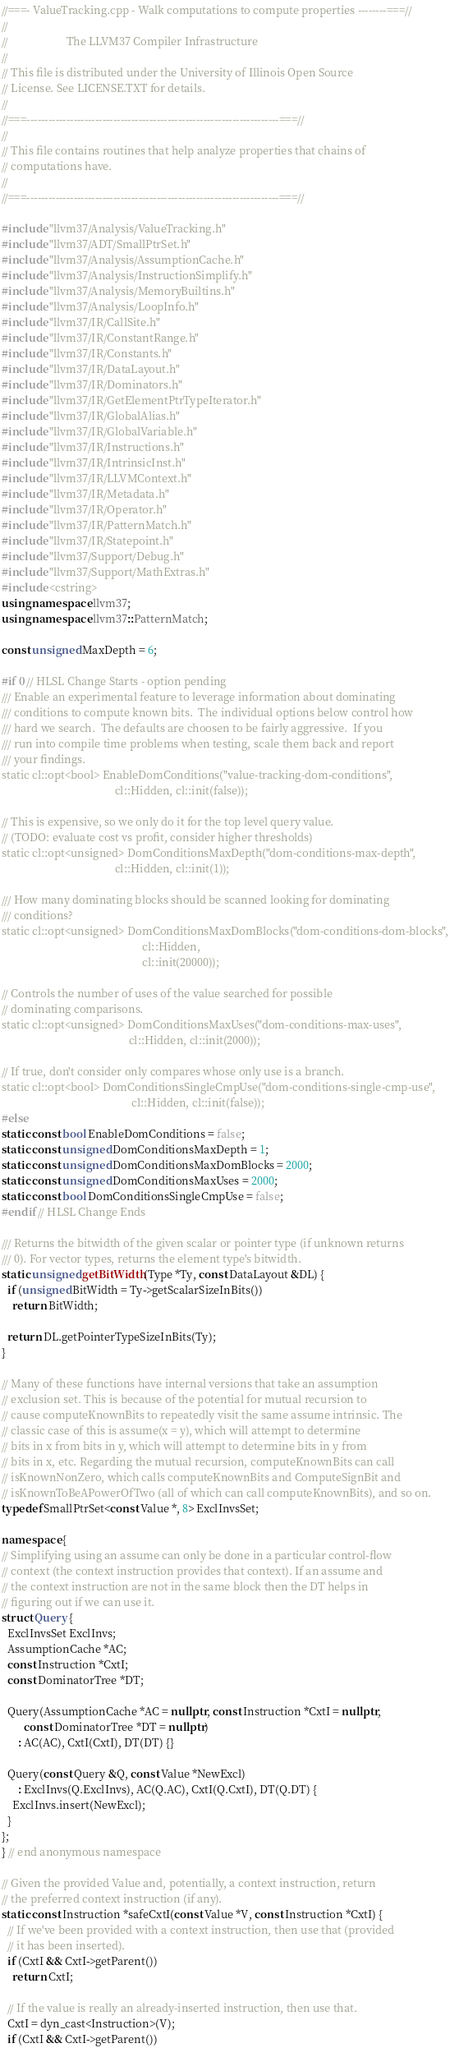Convert code to text. <code><loc_0><loc_0><loc_500><loc_500><_C++_>//===- ValueTracking.cpp - Walk computations to compute properties --------===//
//
//                     The LLVM37 Compiler Infrastructure
//
// This file is distributed under the University of Illinois Open Source
// License. See LICENSE.TXT for details.
//
//===----------------------------------------------------------------------===//
//
// This file contains routines that help analyze properties that chains of
// computations have.
//
//===----------------------------------------------------------------------===//

#include "llvm37/Analysis/ValueTracking.h"
#include "llvm37/ADT/SmallPtrSet.h"
#include "llvm37/Analysis/AssumptionCache.h"
#include "llvm37/Analysis/InstructionSimplify.h"
#include "llvm37/Analysis/MemoryBuiltins.h"
#include "llvm37/Analysis/LoopInfo.h"
#include "llvm37/IR/CallSite.h"
#include "llvm37/IR/ConstantRange.h"
#include "llvm37/IR/Constants.h"
#include "llvm37/IR/DataLayout.h"
#include "llvm37/IR/Dominators.h"
#include "llvm37/IR/GetElementPtrTypeIterator.h"
#include "llvm37/IR/GlobalAlias.h"
#include "llvm37/IR/GlobalVariable.h"
#include "llvm37/IR/Instructions.h"
#include "llvm37/IR/IntrinsicInst.h"
#include "llvm37/IR/LLVMContext.h"
#include "llvm37/IR/Metadata.h"
#include "llvm37/IR/Operator.h"
#include "llvm37/IR/PatternMatch.h"
#include "llvm37/IR/Statepoint.h"
#include "llvm37/Support/Debug.h"
#include "llvm37/Support/MathExtras.h"
#include <cstring>
using namespace llvm37;
using namespace llvm37::PatternMatch;

const unsigned MaxDepth = 6;

#if 0 // HLSL Change Starts - option pending
/// Enable an experimental feature to leverage information about dominating
/// conditions to compute known bits.  The individual options below control how
/// hard we search.  The defaults are choosen to be fairly aggressive.  If you
/// run into compile time problems when testing, scale them back and report
/// your findings.
static cl::opt<bool> EnableDomConditions("value-tracking-dom-conditions",
                                         cl::Hidden, cl::init(false));

// This is expensive, so we only do it for the top level query value.
// (TODO: evaluate cost vs profit, consider higher thresholds)
static cl::opt<unsigned> DomConditionsMaxDepth("dom-conditions-max-depth",
                                         cl::Hidden, cl::init(1));

/// How many dominating blocks should be scanned looking for dominating
/// conditions?
static cl::opt<unsigned> DomConditionsMaxDomBlocks("dom-conditions-dom-blocks",
                                                   cl::Hidden,
                                                   cl::init(20000));

// Controls the number of uses of the value searched for possible
// dominating comparisons.
static cl::opt<unsigned> DomConditionsMaxUses("dom-conditions-max-uses",
                                              cl::Hidden, cl::init(2000));

// If true, don't consider only compares whose only use is a branch.
static cl::opt<bool> DomConditionsSingleCmpUse("dom-conditions-single-cmp-use",
                                               cl::Hidden, cl::init(false));
#else
static const bool EnableDomConditions = false;
static const unsigned DomConditionsMaxDepth = 1;
static const unsigned DomConditionsMaxDomBlocks = 2000;
static const unsigned DomConditionsMaxUses = 2000;
static const bool DomConditionsSingleCmpUse = false;
#endif // HLSL Change Ends

/// Returns the bitwidth of the given scalar or pointer type (if unknown returns
/// 0). For vector types, returns the element type's bitwidth.
static unsigned getBitWidth(Type *Ty, const DataLayout &DL) {
  if (unsigned BitWidth = Ty->getScalarSizeInBits())
    return BitWidth;

  return DL.getPointerTypeSizeInBits(Ty);
}

// Many of these functions have internal versions that take an assumption
// exclusion set. This is because of the potential for mutual recursion to
// cause computeKnownBits to repeatedly visit the same assume intrinsic. The
// classic case of this is assume(x = y), which will attempt to determine
// bits in x from bits in y, which will attempt to determine bits in y from
// bits in x, etc. Regarding the mutual recursion, computeKnownBits can call
// isKnownNonZero, which calls computeKnownBits and ComputeSignBit and
// isKnownToBeAPowerOfTwo (all of which can call computeKnownBits), and so on.
typedef SmallPtrSet<const Value *, 8> ExclInvsSet;

namespace {
// Simplifying using an assume can only be done in a particular control-flow
// context (the context instruction provides that context). If an assume and
// the context instruction are not in the same block then the DT helps in
// figuring out if we can use it.
struct Query {
  ExclInvsSet ExclInvs;
  AssumptionCache *AC;
  const Instruction *CxtI;
  const DominatorTree *DT;

  Query(AssumptionCache *AC = nullptr, const Instruction *CxtI = nullptr,
        const DominatorTree *DT = nullptr)
      : AC(AC), CxtI(CxtI), DT(DT) {}

  Query(const Query &Q, const Value *NewExcl)
      : ExclInvs(Q.ExclInvs), AC(Q.AC), CxtI(Q.CxtI), DT(Q.DT) {
    ExclInvs.insert(NewExcl);
  }
};
} // end anonymous namespace

// Given the provided Value and, potentially, a context instruction, return
// the preferred context instruction (if any).
static const Instruction *safeCxtI(const Value *V, const Instruction *CxtI) {
  // If we've been provided with a context instruction, then use that (provided
  // it has been inserted).
  if (CxtI && CxtI->getParent())
    return CxtI;

  // If the value is really an already-inserted instruction, then use that.
  CxtI = dyn_cast<Instruction>(V);
  if (CxtI && CxtI->getParent())</code> 